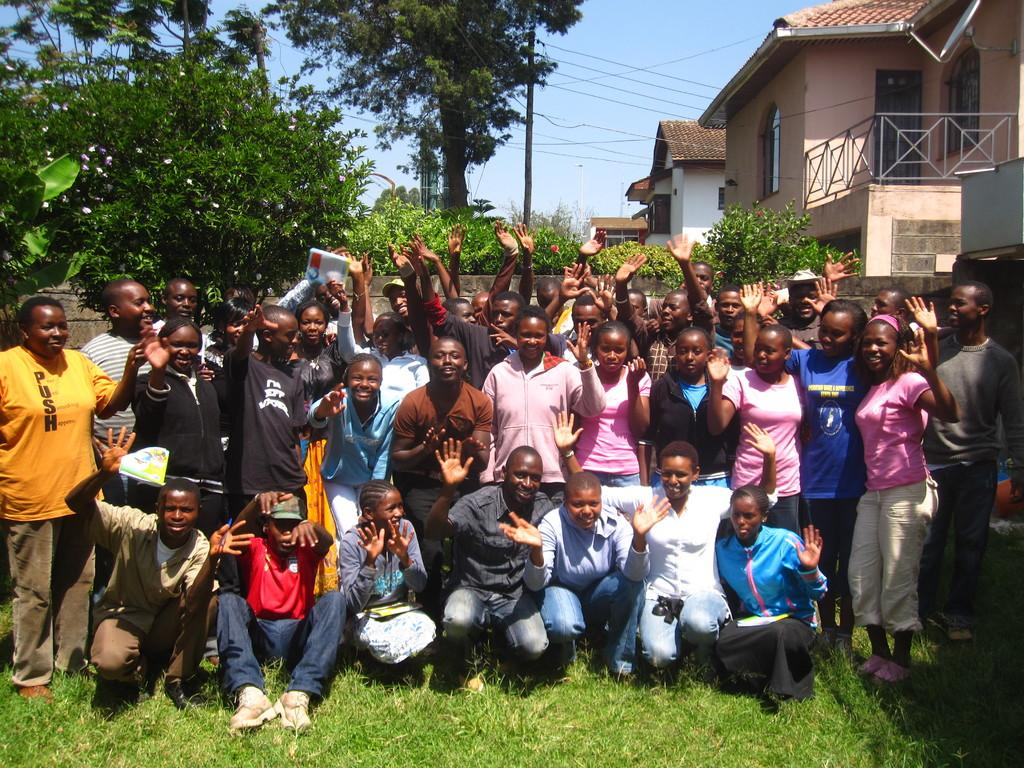What can be seen in the image? There is a group of people in the image. What is located on the right side of the image? There are houses on the right side of the image. What is on the left side of the image? There are trees on the left side of the image. How many sticks are being held by the people in the image? There are no sticks visible in the image. What color is the head of the person in the image? The image does not show the people's heads, so we cannot determine the color of their hair or any headwear. 